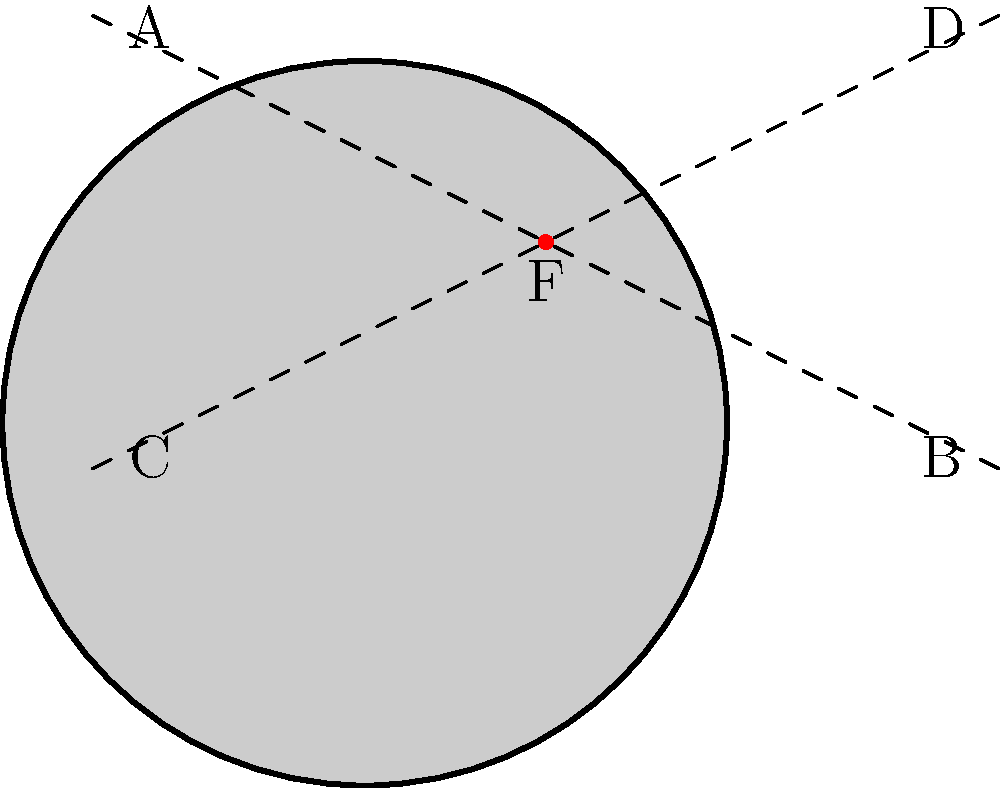In the photograph of a large-scale outdoor sculpture shown above, which point represents the focal point that draws the viewer's attention and creates visual balance in the composition? To identify the focal point in this photograph of a large-scale outdoor sculpture, let's follow these steps:

1. Observe the overall composition: The image shows a circular sculpture with intersecting diagonal lines.

2. Understand the concept of focal point: In photography, the focal point is the area that draws the viewer's attention and often creates visual balance in the composition.

3. Analyze the geometric elements:
   a. The sculpture is represented by a circular shape.
   b. There are two intersecting diagonal lines (dashed) that create visual interest.
   c. Five points are labeled: A, B, C, D, and F.

4. Consider the properties of a strong focal point:
   a. It's often centrally located or at an intersection of important compositional lines.
   b. It stands out visually, often through contrast or unique positioning.

5. Evaluate each point:
   A, B, C, and D are positioned at the edges of the composition, making them less likely to be focal points.
   F is located at the center of the circle and at the intersection of the diagonal lines.

6. Conclusion: Point F is the most likely focal point because:
   - It's at the center of the circular sculpture.
   - It's at the intersection of the diagonal lines, creating visual interest.
   - Its central position naturally draws the viewer's eye.
   - It's marked in red, further emphasizing its importance in the composition.

Therefore, point F represents the focal point that draws the viewer's attention and creates visual balance in the composition.
Answer: F 